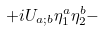Convert formula to latex. <formula><loc_0><loc_0><loc_500><loc_500>+ i U _ { a ; b } \eta ^ { a } _ { 1 } \eta ^ { b } _ { 2 } -</formula> 